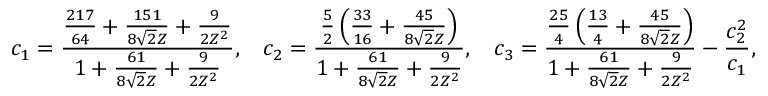Convert formula to latex. <formula><loc_0><loc_0><loc_500><loc_500>c _ { 1 } = \frac { \frac { 2 1 7 } { 6 4 } + \frac { 1 5 1 } { 8 \sqrt { 2 } Z } + \frac { 9 } { 2 Z ^ { 2 } } } { 1 + \frac { 6 1 } { 8 \sqrt { 2 } Z } + \frac { 9 } { 2 Z ^ { 2 } } } , \, c _ { 2 } = \frac { \frac { 5 } { 2 } \left ( \frac { 3 3 } { 1 6 } + \frac { 4 5 } { 8 \sqrt { 2 } Z } \right ) } { 1 + \frac { 6 1 } { 8 \sqrt { 2 } Z } + \frac { 9 } { 2 Z ^ { 2 } } } , \, c _ { 3 } = \frac { \frac { 2 5 } { 4 } \left ( \frac { 1 3 } { 4 } + \frac { 4 5 } { 8 \sqrt { 2 } Z } \right ) } { 1 + \frac { 6 1 } { 8 \sqrt { 2 } Z } + \frac { 9 } { 2 Z ^ { 2 } } } - \frac { c _ { 2 } ^ { 2 } } { c _ { 1 } } ,</formula> 